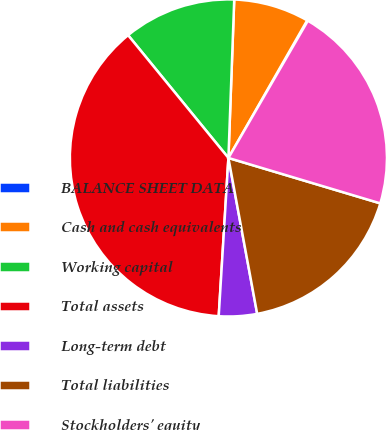Convert chart. <chart><loc_0><loc_0><loc_500><loc_500><pie_chart><fcel>BALANCE SHEET DATA<fcel>Cash and cash equivalents<fcel>Working capital<fcel>Total assets<fcel>Long-term debt<fcel>Total liabilities<fcel>Stockholders' equity<nl><fcel>0.08%<fcel>7.69%<fcel>11.49%<fcel>38.12%<fcel>3.88%<fcel>17.47%<fcel>21.27%<nl></chart> 